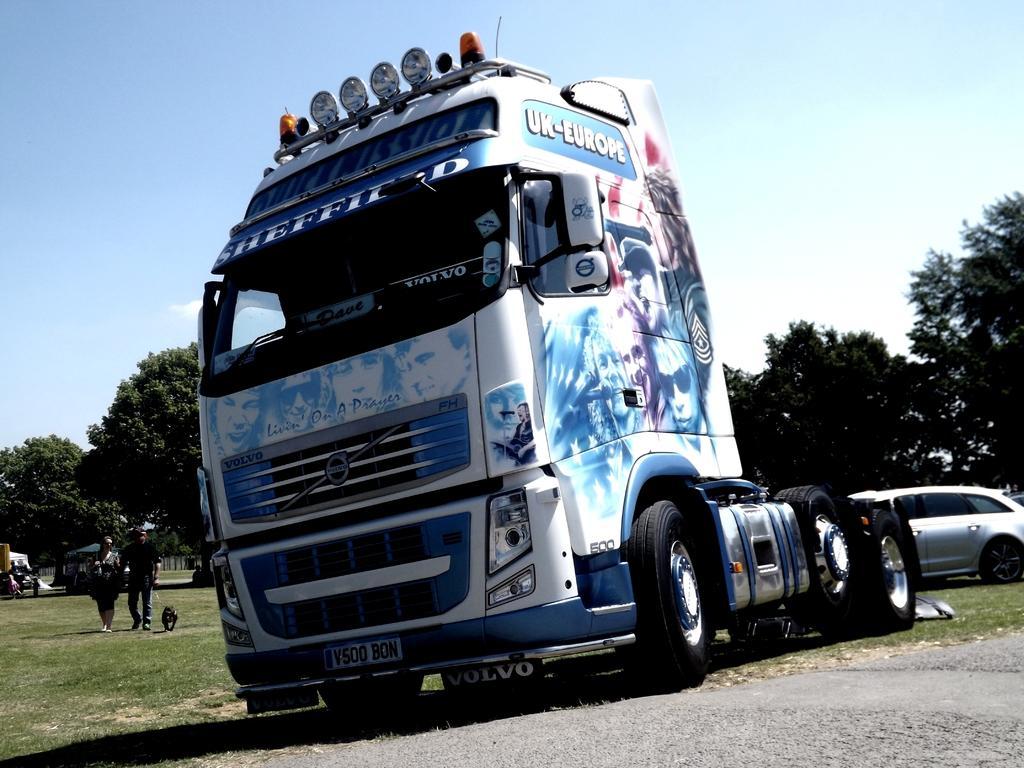Could you give a brief overview of what you see in this image? In this image I can see few vehicles, trees, few people. The sky is in blue and white color. 